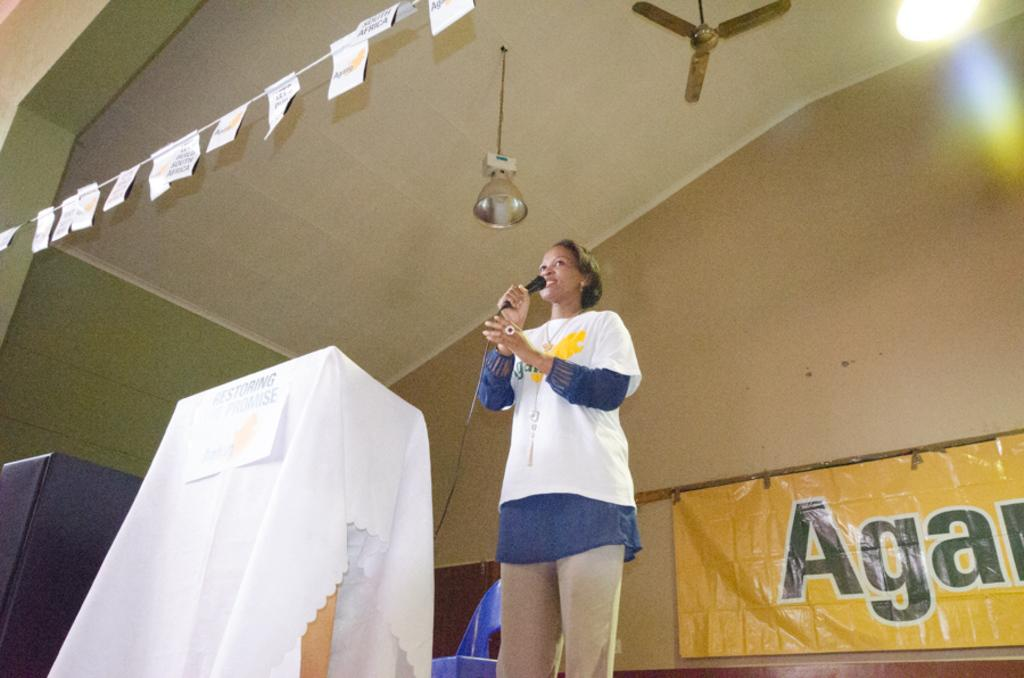<image>
Provide a brief description of the given image. The yellow sign behind the speaker begins with the letters "Aga". 